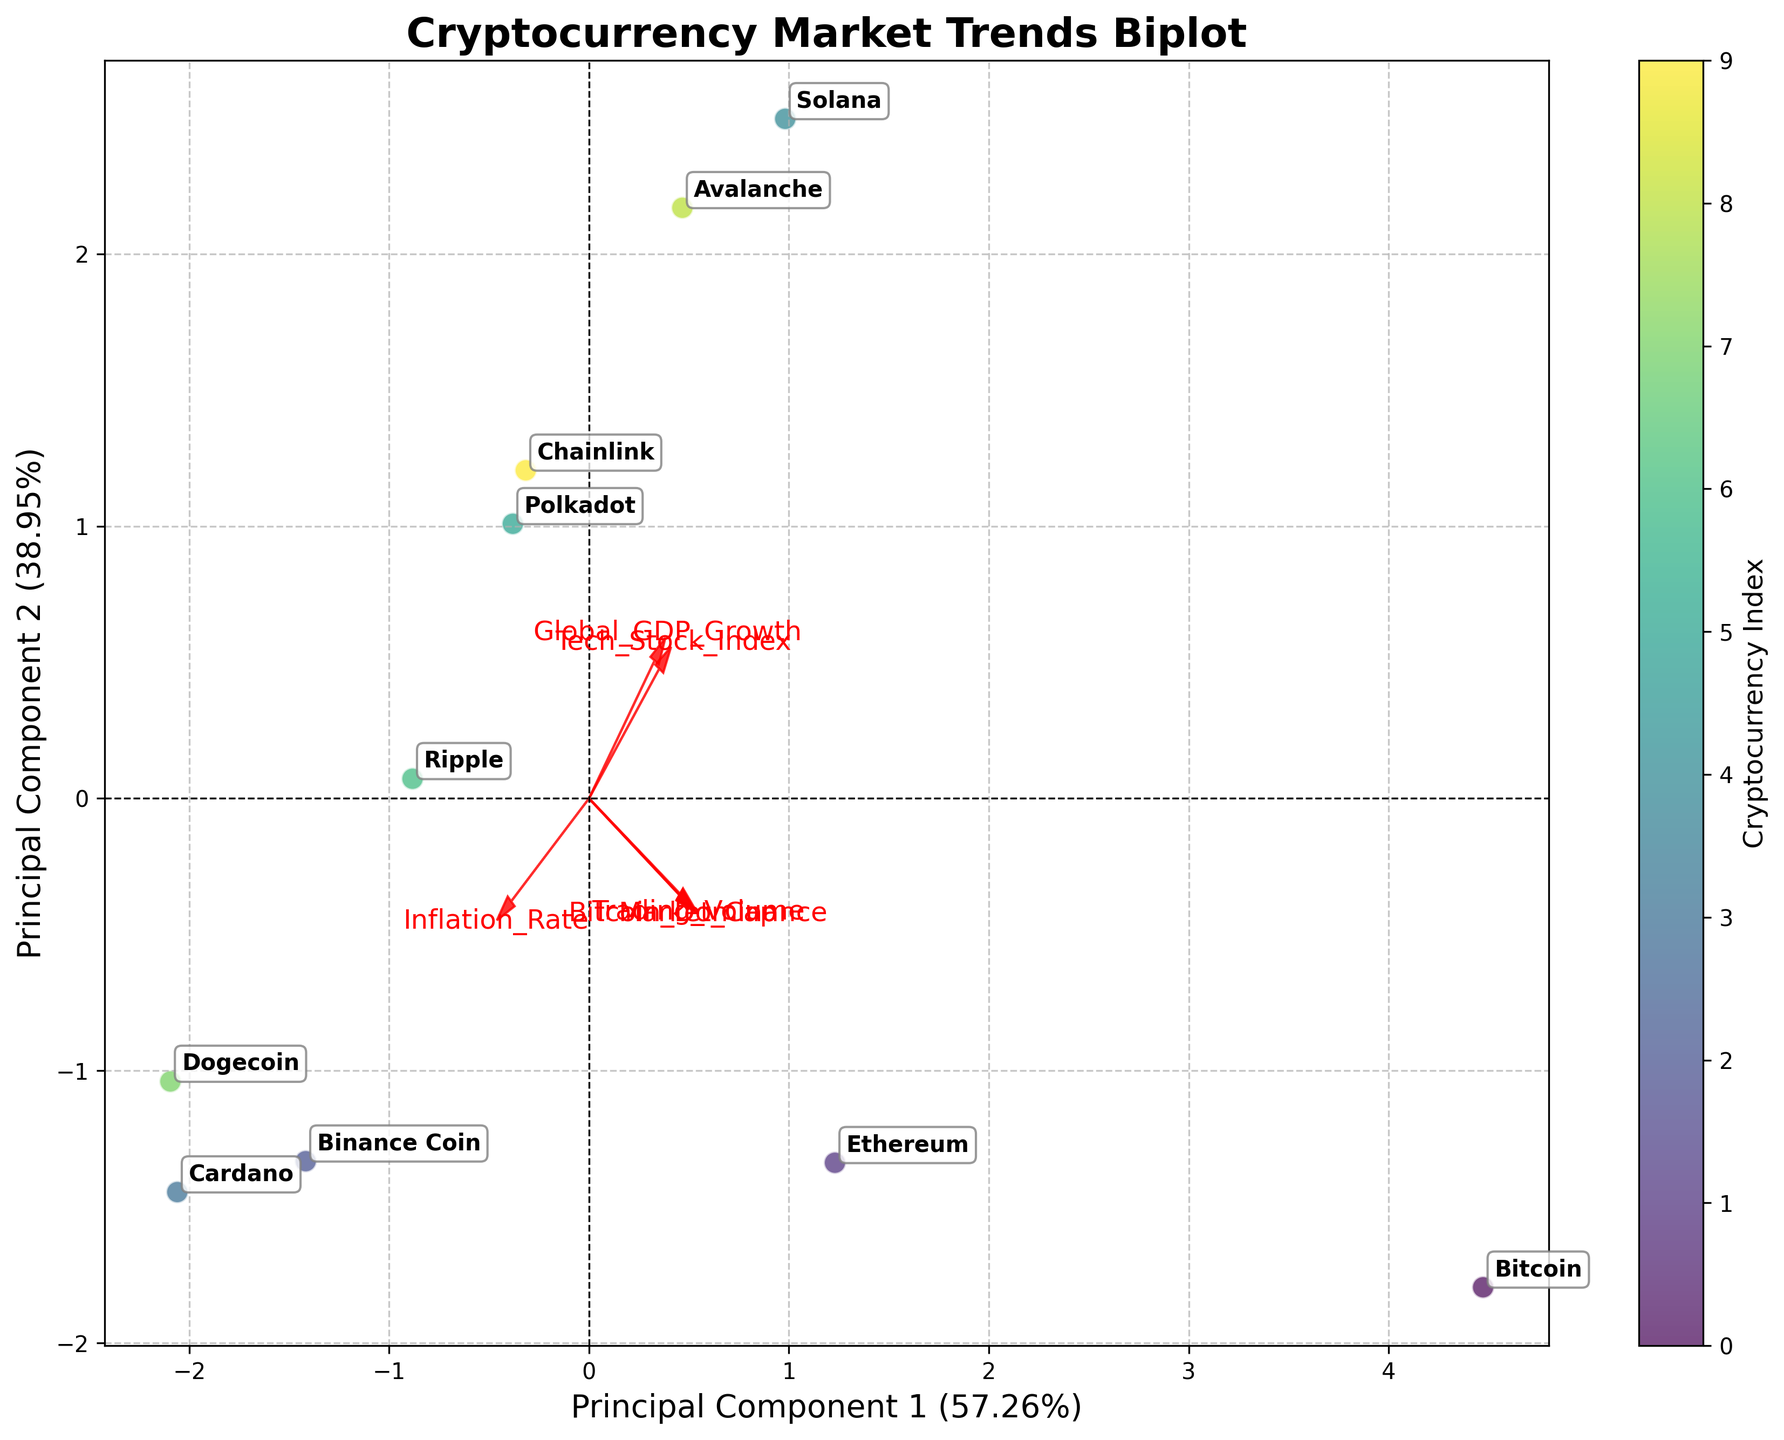What is the title of the plot? The title is located at the top of the plot, usually in a larger and bold font. For the given plot, the title is "Cryptocurrency Market Trends Biplot."
Answer: Cryptocurrency Market Trends Biplot How many data points are represented in the plot? Data points in the plot represent cryptocurrencies, often marked by labels or symbols. By counting the labels, we can see there are 10 data points, each representing a different cryptocurrency.
Answer: 10 Which cryptocurrency has the highest value on Principal Component 1? By observing the positions of the data points along the x-axis (Principal Component 1), the cryptocurrency positioned furthest to the right indicates the highest value on this component.
Answer: Bitcoin Which features influence Principal Component 1 the most? Features influencing Principal Component 1 the most are identified by the direction and length of the red arrows. The ones with the longest arrows pointing more along the x-axis have the most influence.
Answer: Market_Cap and Bitcoin_Dominance How are Bitcoin and Ethereum related in Principal Component 2? By looking at the y-axis (Principal Component 2) positions for Bitcoin and Ethereum, we can compare their values. Ethereum is positioned higher on the y-axis (Principal Component 2), indicating a higher value compared to Bitcoin.
Answer: Ethereum is higher What is the relationship between Trading Volume and Bitcoin Dominance? To determine the relationship, we look at the direction of the arrows representing these features. If they point in similar directions, there's a positive correlation; if they are opposite, there's a negative correlation.
Answer: Positive correlation Which two features are most closely aligned in the same direction? Closely aligned features will have arrows pointing in a very similar direction. By inspecting the direction of all arrows, we can see that Market_Cap and Bitcoin_Dominance have the most closely aligned arrows.
Answer: Market_Cap and Bitcoin_Dominance Which cryptocurrency has a higher Principal Component 2 value than Cardano? By comparing the y-axis (Principal Component 2) values of all cryptocurrencies, Ripple is positioned higher along the y-axis compared to Cardano.
Answer: Ripple Which feature is most perpendicular to Global GDP Growth? Features most perpendicular to another will have arrows that form a right angle. By examining the plot, Trading Volume and Global GDP Growth arrows are nearly perpendicular to each other.
Answer: Trading Volume How does Tech_Stock_Index relate to Inflation_Rate in the plot? By observing the directions of the arrows for Tech_Stock_Index and Inflation_Rate, we can see they are almost opposite in direction, indicating they are inversely related.
Answer: Inversely related 